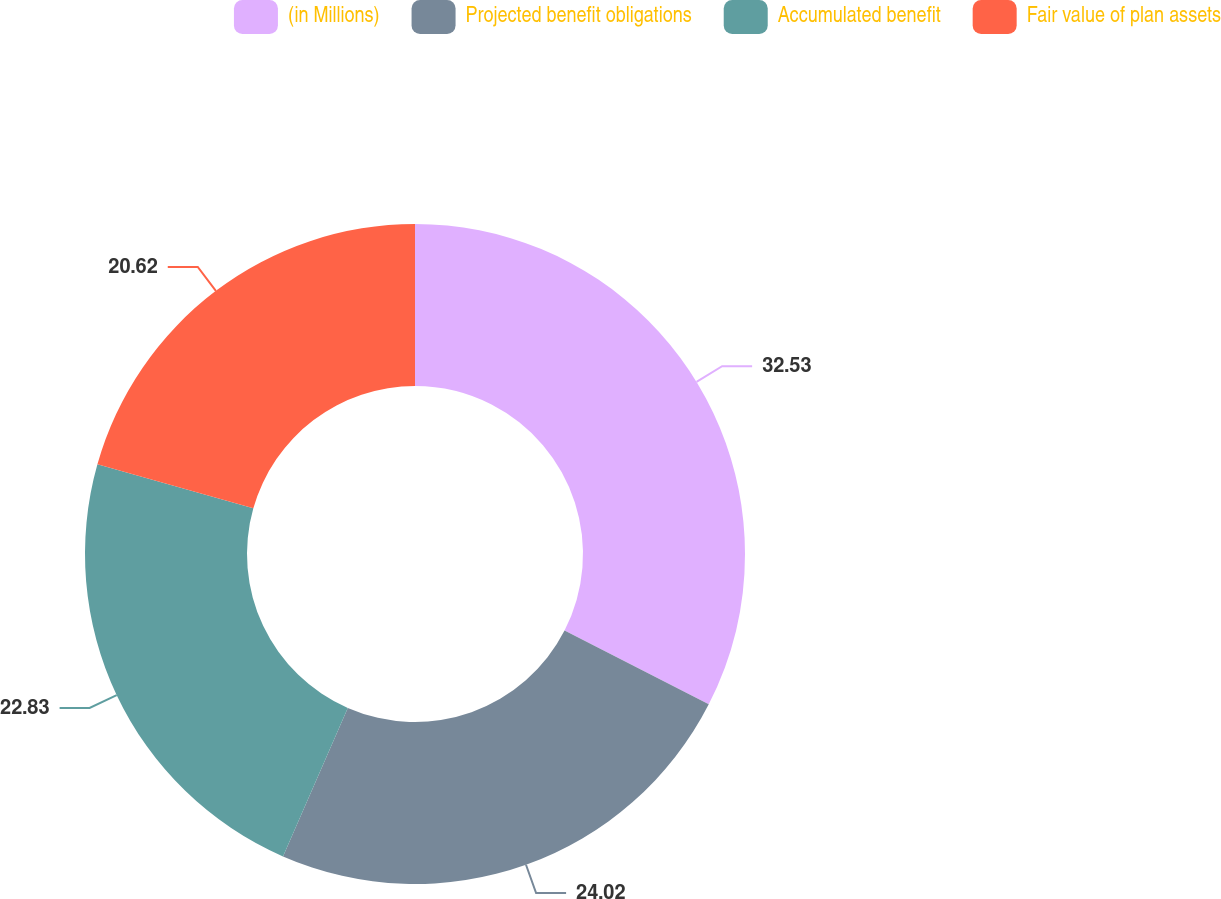Convert chart. <chart><loc_0><loc_0><loc_500><loc_500><pie_chart><fcel>(in Millions)<fcel>Projected benefit obligations<fcel>Accumulated benefit<fcel>Fair value of plan assets<nl><fcel>32.53%<fcel>24.02%<fcel>22.83%<fcel>20.62%<nl></chart> 